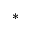Convert formula to latex. <formula><loc_0><loc_0><loc_500><loc_500>^ { * }</formula> 